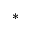Convert formula to latex. <formula><loc_0><loc_0><loc_500><loc_500>^ { * }</formula> 